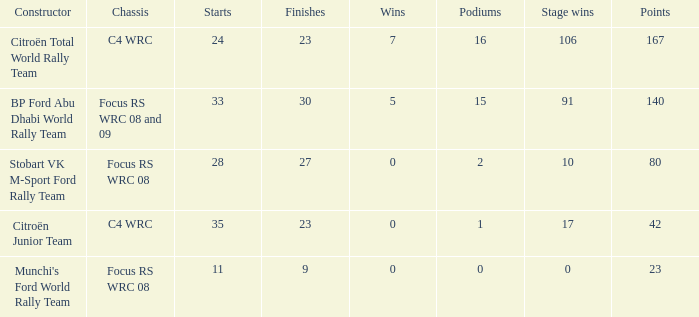What is the highest points when the chassis is focus rs wrc 08 and 09 and the stage wins is more than 91? None. 